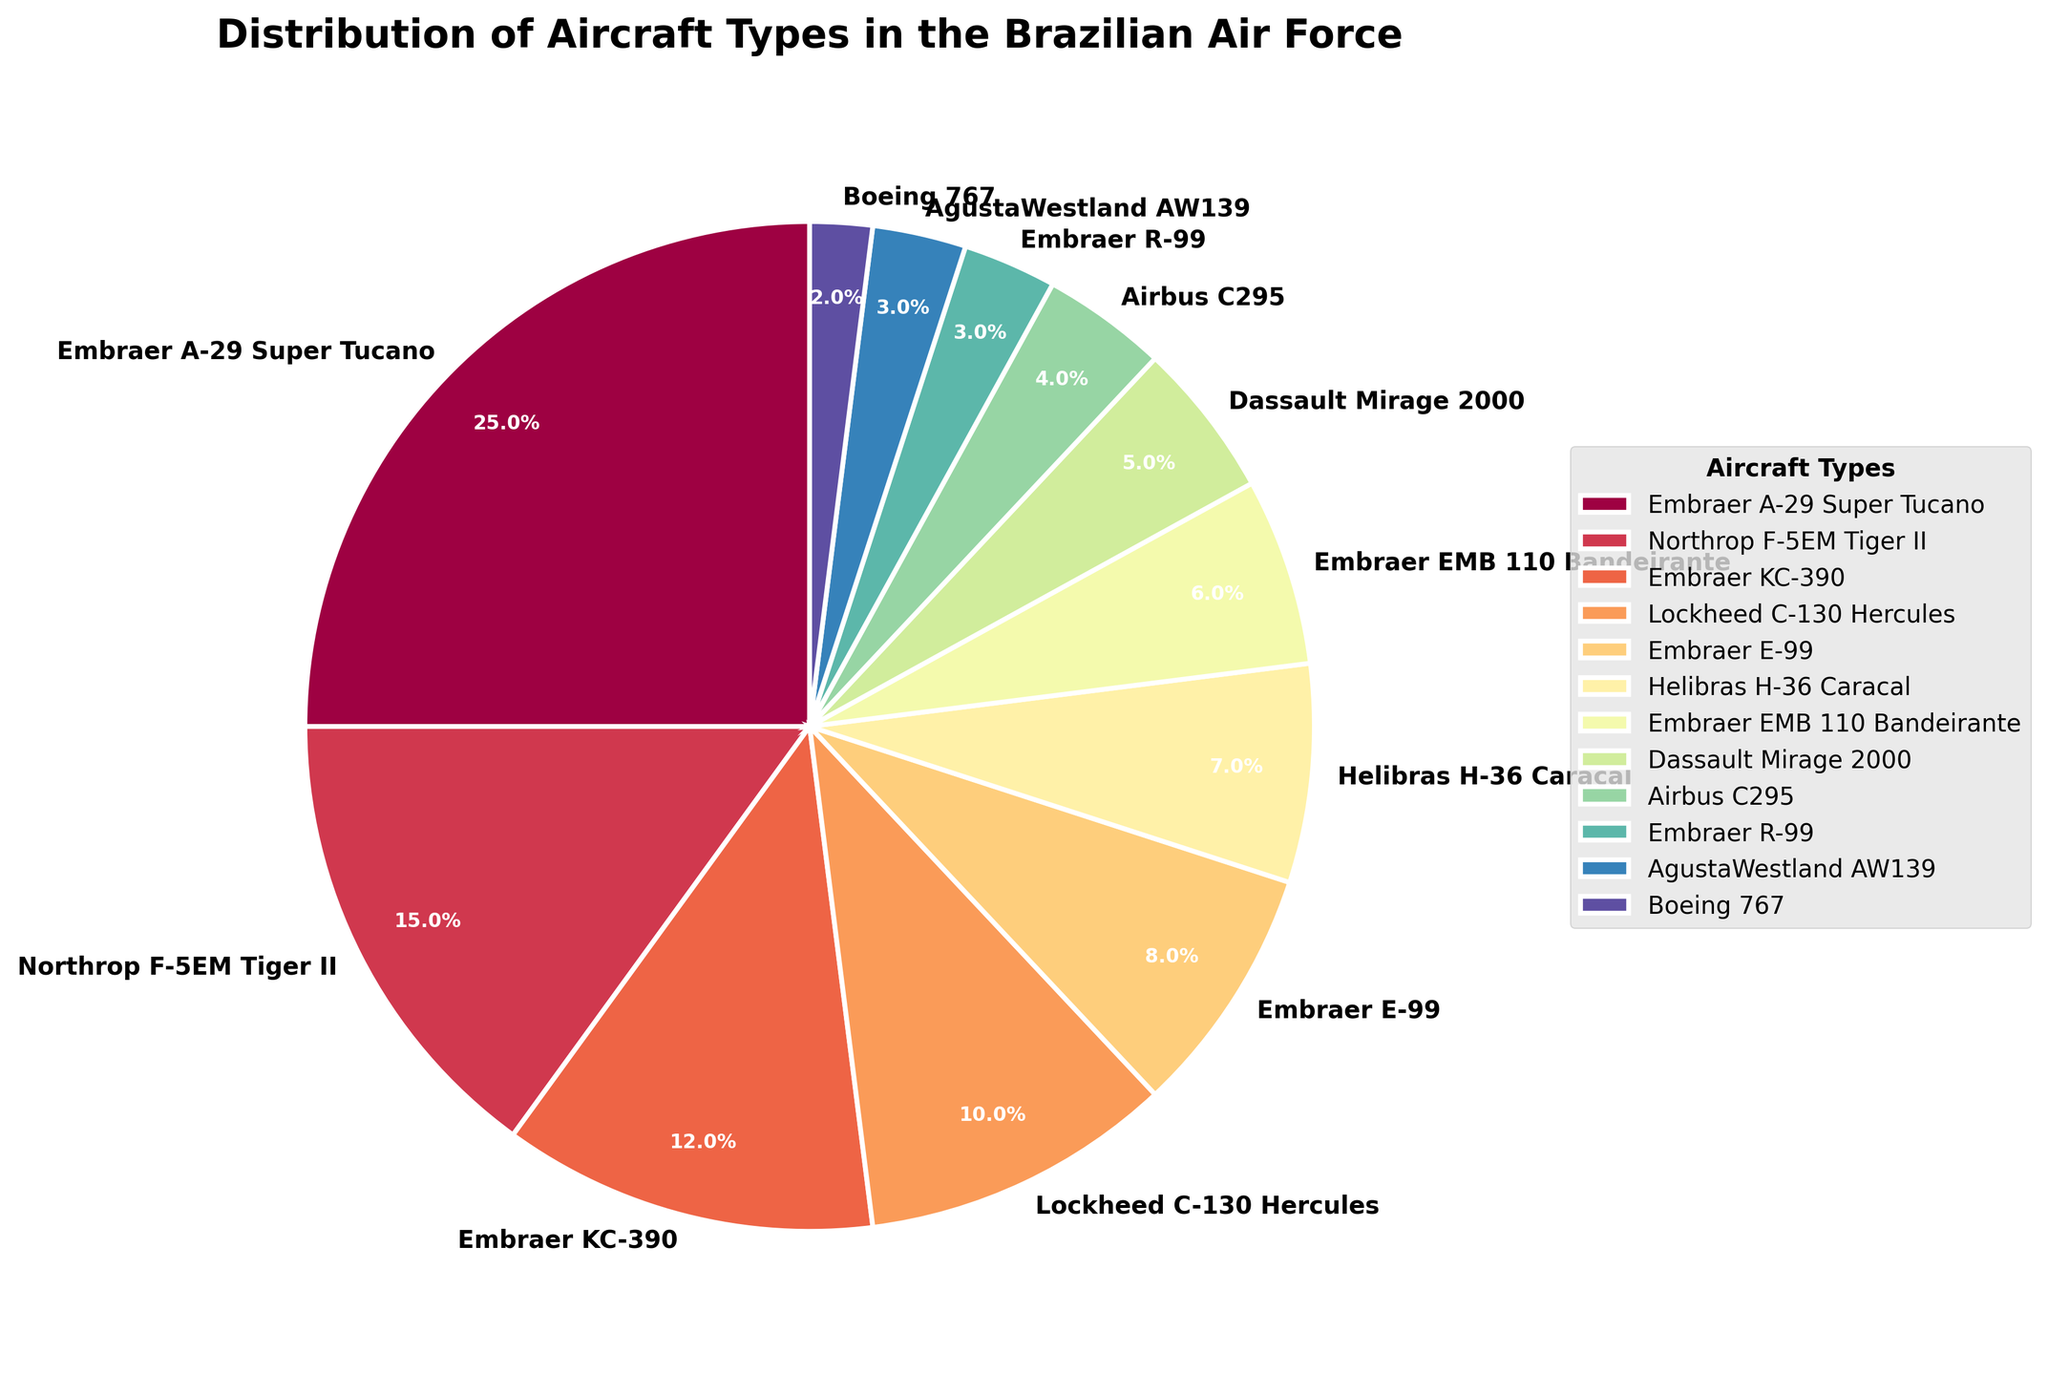Which aircraft type has the highest percentage in the Brazilian Air Force? The Embraer A-29 Super Tucano has the highest percentage at 25%, which can be seen as the largest slice in the pie chart.
Answer: Embraer A-29 Super Tucano What is the combined percentage of Embraer KC-390 and Lockheed C-130 Hercules aircraft types? The Embraer KC-390 represents 12% and the Lockheed C-130 Hercules represents 10%. Summing these percentages gives 12% + 10% = 22%.
Answer: 22% How does the percentage of Northrop F-5EM Tiger II compare to that of Embraer E-99? The Northrop F-5EM Tiger II has a percentage of 15%, while the Embraer E-99 has a percentage of 8%. Comparing these percentages, 15% is greater than 8%.
Answer: Northrop F-5EM Tiger II > Embraer E-99 Which aircraft type occupies the smallest portion of the pie chart? The Boeing 767 occupies the smallest portion of the pie chart with a percentage of 2%.
Answer: Boeing 767 Do Embraer aircraft types collectively make up more than half the pie chart? The Embraer aircraft types and their percentages are: A-29 Super Tucano (25%), KC-390 (12%), E-99 (8%), EMB 110 Bandeirante (6%), and R-99 (3%). Adding these gives 25% + 12% + 8% + 6% + 3% = 54%. Thus, Embraer aircraft collectively make up more than half of the pie chart.
Answer: Yes Which two aircraft types have the closest percentages? The AgustaWestland AW139 and Embraer R-99 both have a percentage of 3%, making them the closest in percentage.
Answer: AgustaWestland AW139 and Embraer R-99 What is the difference in percentage between the Helibras H-36 Caracal and the Airbus C295? The percentage for the Helibras H-36 Caracal is 7% and for the Airbus C295 is 4%. The difference is 7% - 4% = 3%.
Answer: 3% What percentage of the pie chart does the Helibras H-36 Caracal represent visually and numerically? Visually, the Helibras H-36 Caracal corresponds to a moderately small slice. Numerically, it has a percentage of 7%.
Answer: 7% How many aircraft types have a percentage less than 5%? The aircraft types with percentages less than 5% are: Dassault Mirage 2000 (5%), Airbus C295 (4%), Embraer R-99 (3%), AgustaWestland AW139 (3%), and Boeing 767 (2%). Thus, there are 5 aircraft types.
Answer: 5 What is the average percentage of the Dassault Mirage 2000, Airbus C295, and AgustaWestland AW139? The percentages are Dassault Mirage 2000 (5%), Airbus C295 (4%), and AgustaWestland AW139 (3%). Summing these gives 5% + 4% + 3% = 12%. The average is 12% / 3 = 4%.
Answer: 4% 